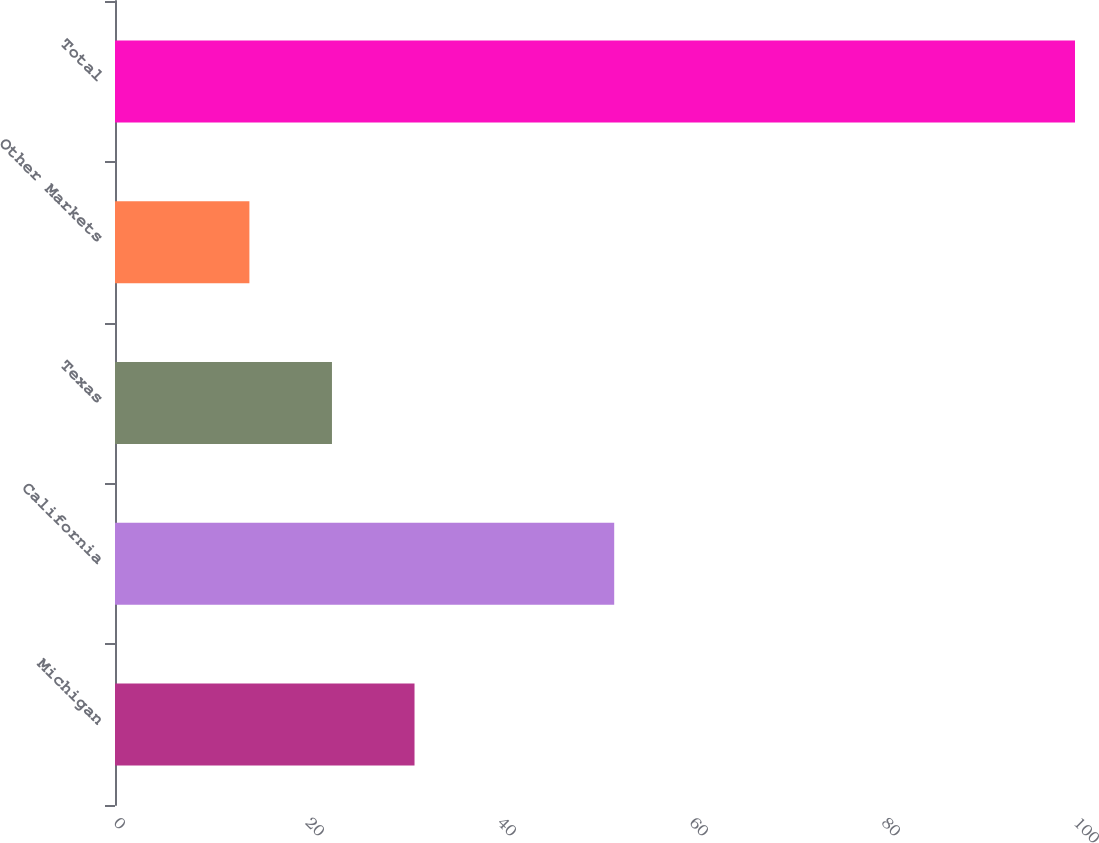<chart> <loc_0><loc_0><loc_500><loc_500><bar_chart><fcel>Michigan<fcel>California<fcel>Texas<fcel>Other Markets<fcel>Total<nl><fcel>31.2<fcel>52<fcel>22.6<fcel>14<fcel>100<nl></chart> 